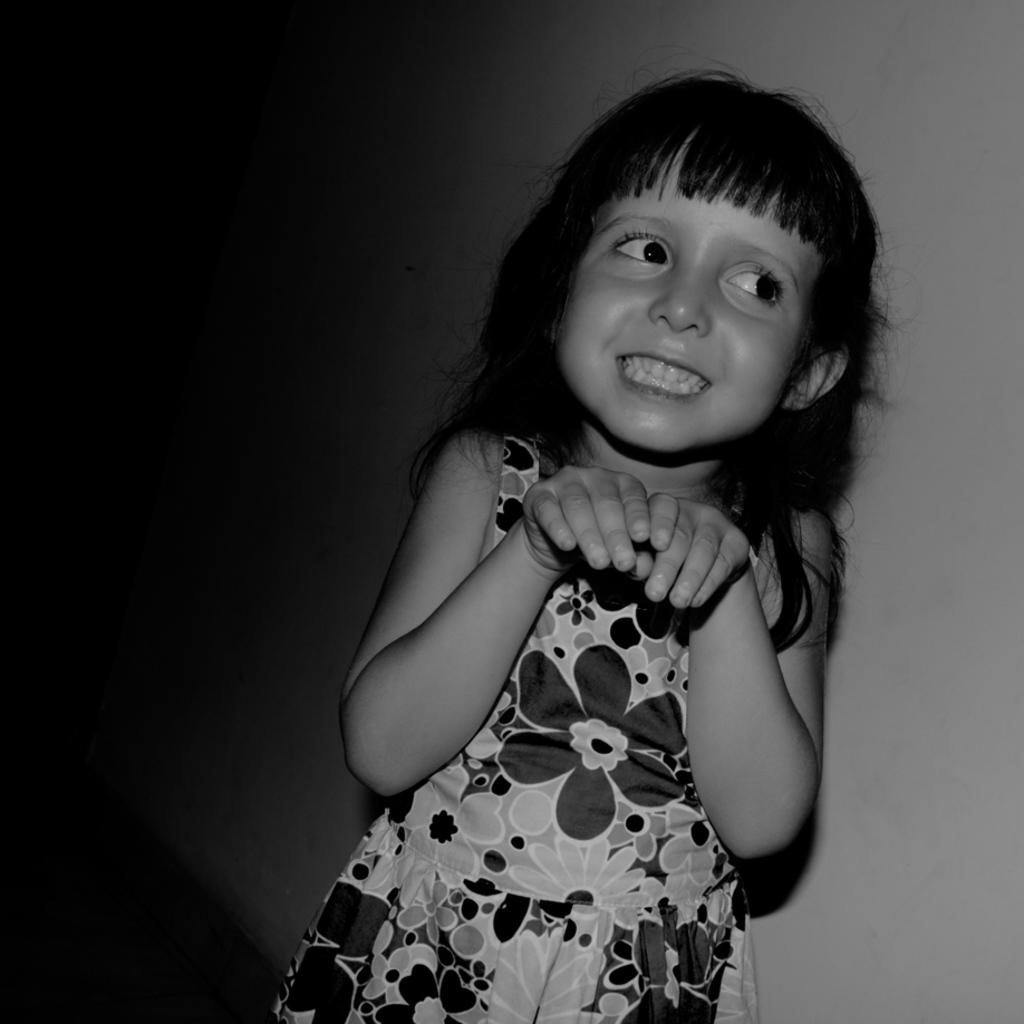What is the color scheme of the image? The image is black and white. Who is present in the image? There is a girl in the image. What is the girl's expression in the image? The girl is smiling in the image. What can be seen in the background of the image? There is a wall in the background of the image. What type of tent can be seen in the image? There is no tent present in the image. How does the girl use chalk to draw in the image? There is no chalk or drawing activity depicted in the image. 